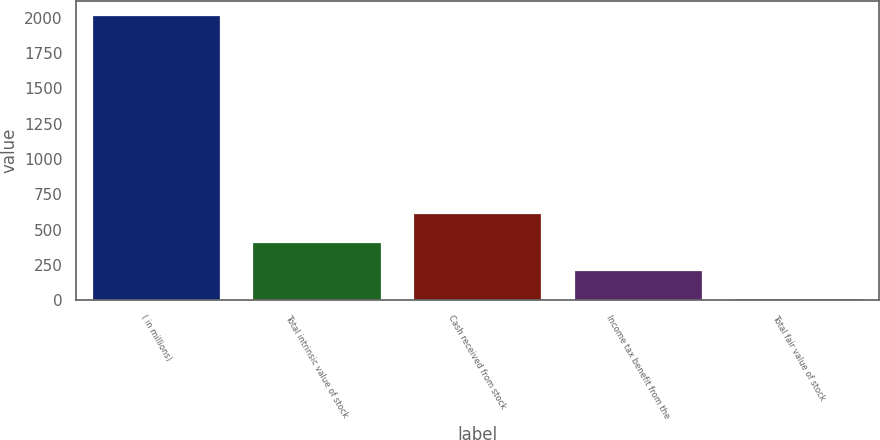<chart> <loc_0><loc_0><loc_500><loc_500><bar_chart><fcel>( in millions)<fcel>Total intrinsic value of stock<fcel>Cash received from stock<fcel>Income tax benefit from the<fcel>Total fair value of stock<nl><fcel>2017<fcel>413.8<fcel>614.2<fcel>213.4<fcel>13<nl></chart> 